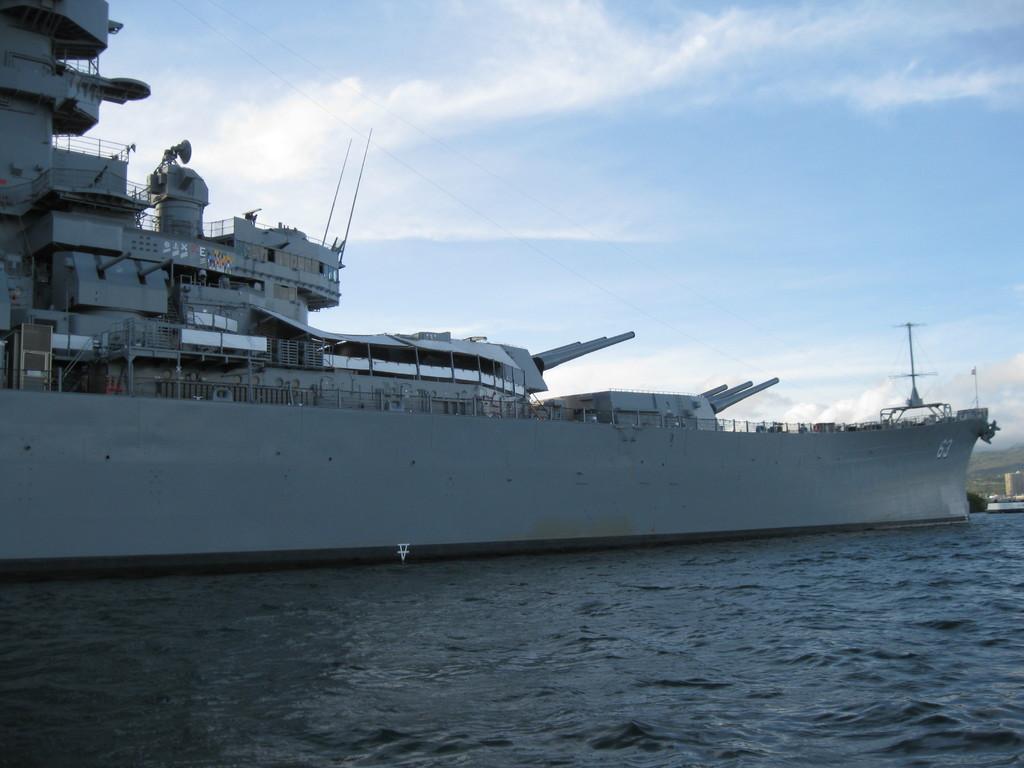Please provide a concise description of this image. In the image we can see there is an ocean and there is a ship docked on the ocean. There is a cloudy sky. 